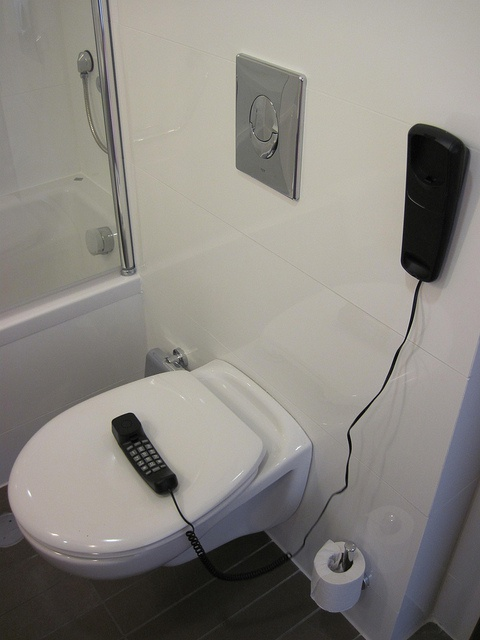Describe the objects in this image and their specific colors. I can see a toilet in gray, darkgray, and black tones in this image. 